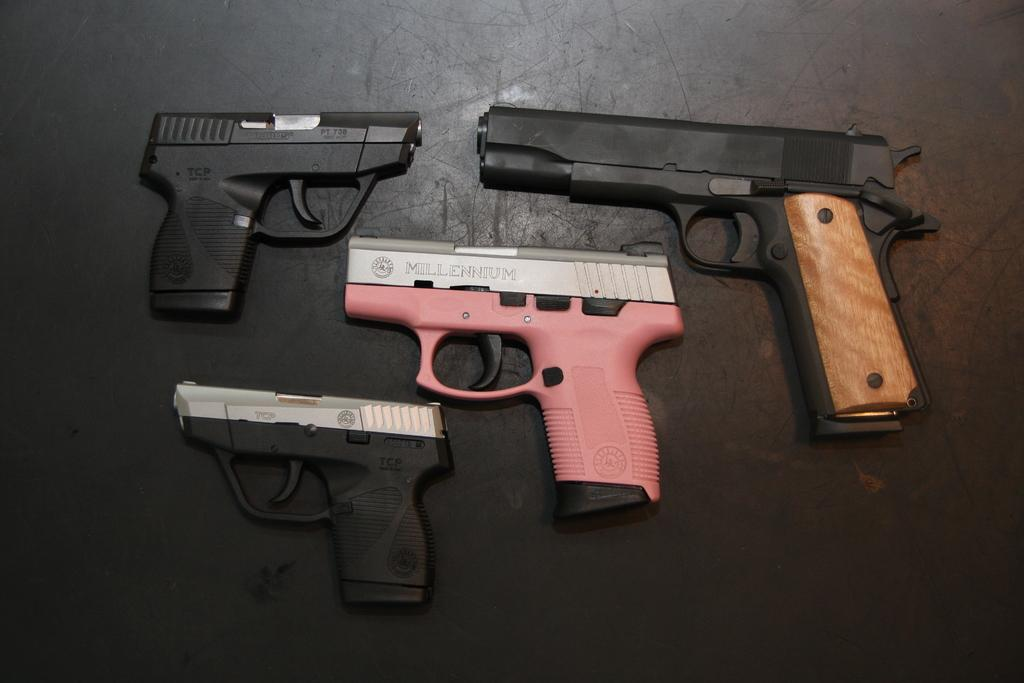What type of objects are present in the image? There are many pistols in the image. Where are the pistols located? The pistols are placed on the floor. How many trucks are parked next to the pistols in the image? There are no trucks present in the image; it only features pistols placed on the floor. What type of animal can be seen grazing near the pistols in the image? There are no animals present in the image; it only features pistols placed on the floor. 